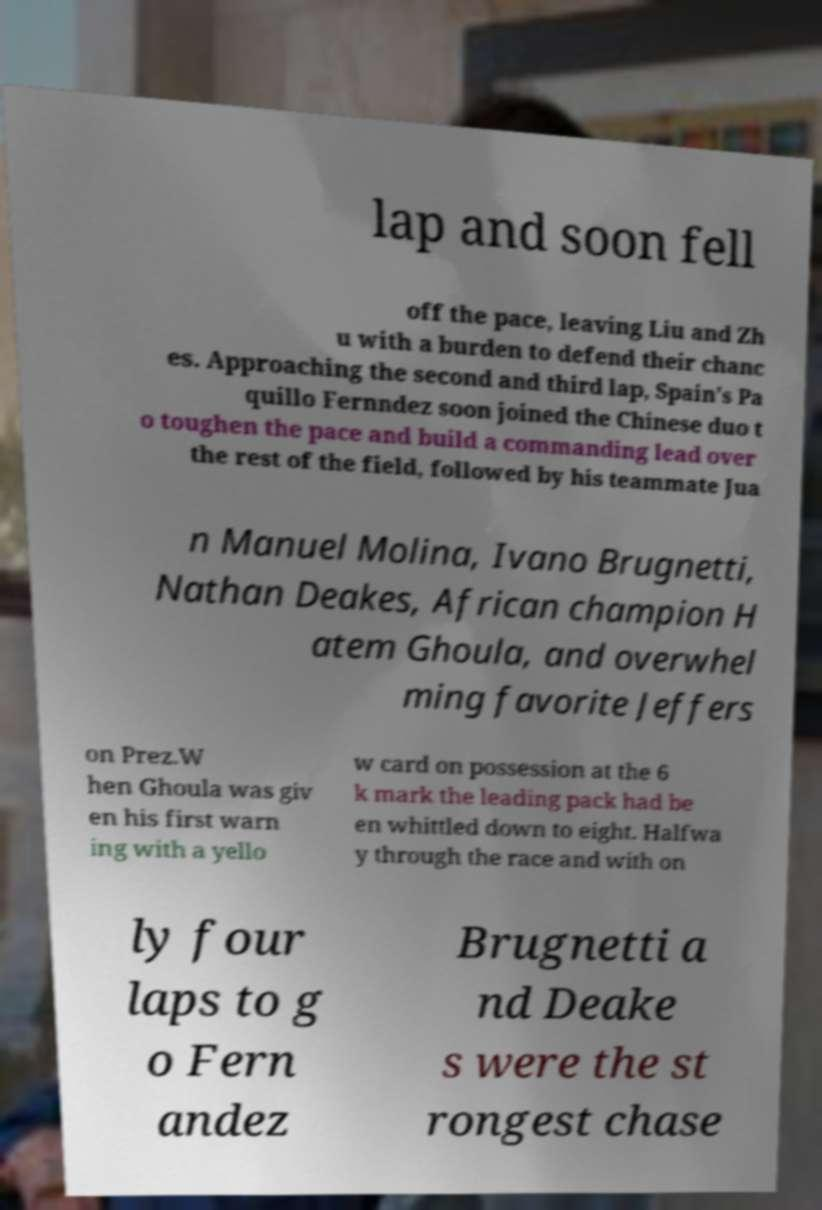Please read and relay the text visible in this image. What does it say? lap and soon fell off the pace, leaving Liu and Zh u with a burden to defend their chanc es. Approaching the second and third lap, Spain's Pa quillo Fernndez soon joined the Chinese duo t o toughen the pace and build a commanding lead over the rest of the field, followed by his teammate Jua n Manuel Molina, Ivano Brugnetti, Nathan Deakes, African champion H atem Ghoula, and overwhel ming favorite Jeffers on Prez.W hen Ghoula was giv en his first warn ing with a yello w card on possession at the 6 k mark the leading pack had be en whittled down to eight. Halfwa y through the race and with on ly four laps to g o Fern andez Brugnetti a nd Deake s were the st rongest chase 